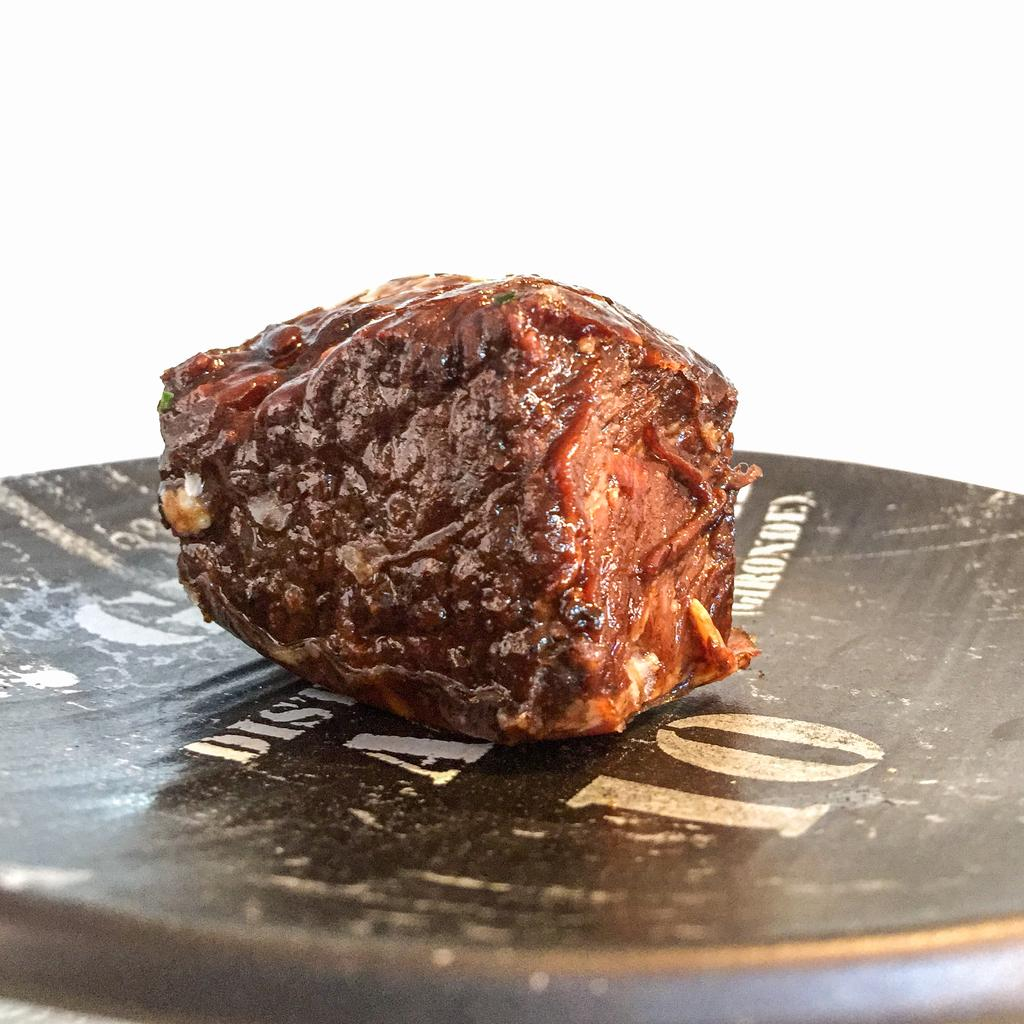What type of objects can be seen in the image? There are food items in the image. How are the food items arranged or presented? The food items are placed on a plate. What type of agreement is being discussed by the food items in the image? There is no indication in the image that the food items are discussing any agreements. 